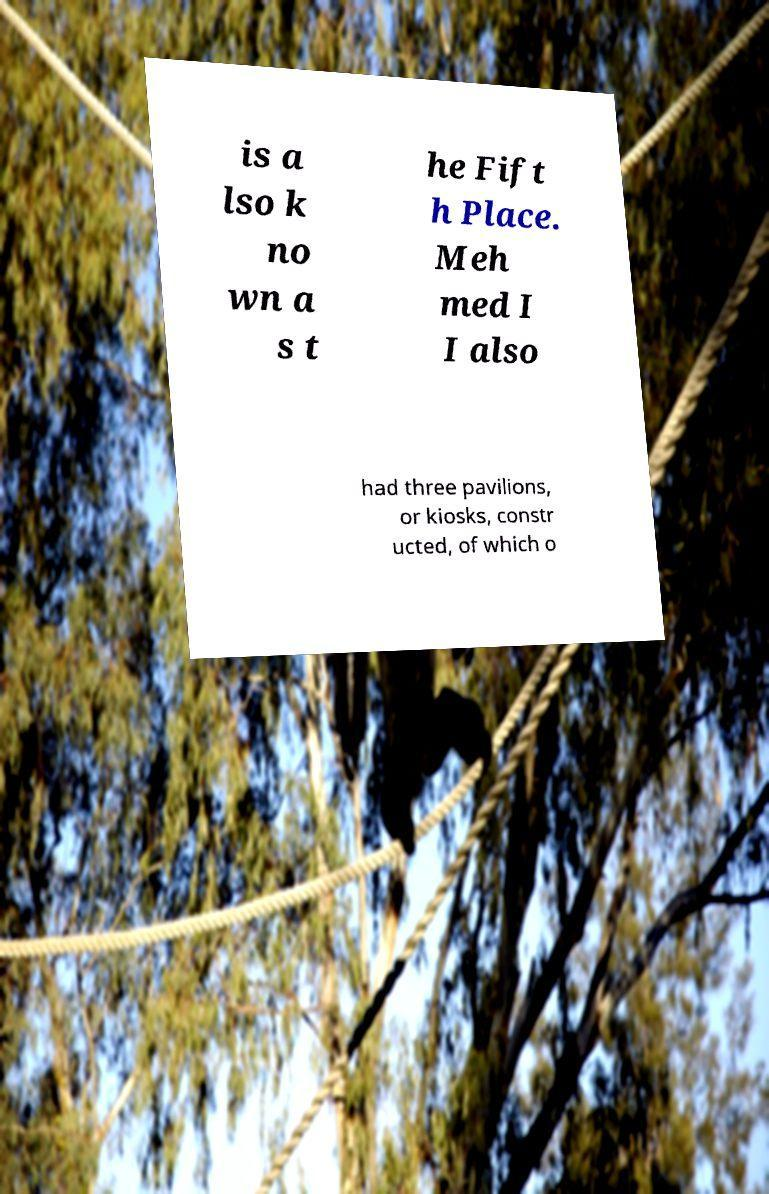Could you assist in decoding the text presented in this image and type it out clearly? is a lso k no wn a s t he Fift h Place. Meh med I I also had three pavilions, or kiosks, constr ucted, of which o 